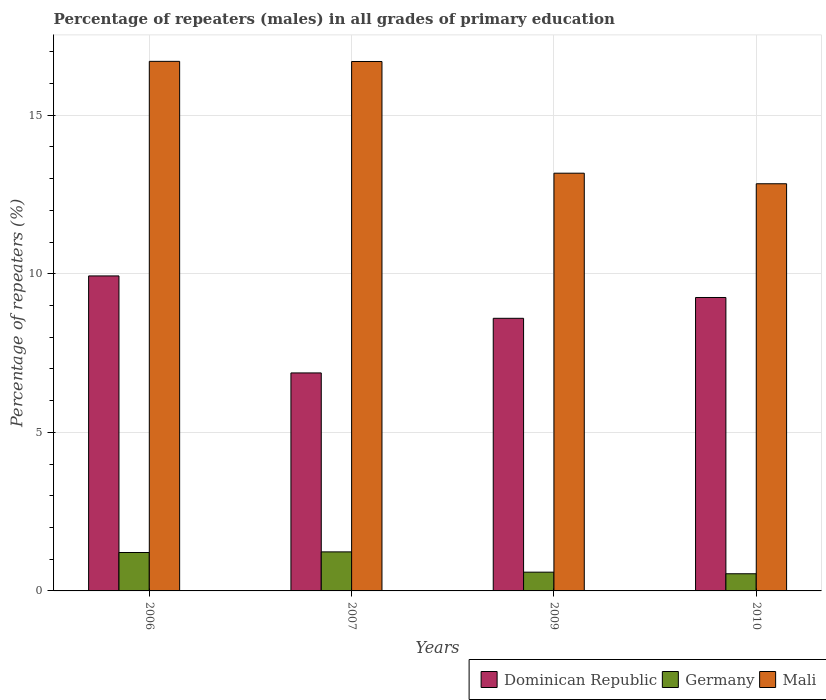Are the number of bars per tick equal to the number of legend labels?
Give a very brief answer. Yes. Are the number of bars on each tick of the X-axis equal?
Provide a short and direct response. Yes. How many bars are there on the 2nd tick from the left?
Ensure brevity in your answer.  3. How many bars are there on the 4th tick from the right?
Your answer should be compact. 3. What is the label of the 4th group of bars from the left?
Offer a very short reply. 2010. In how many cases, is the number of bars for a given year not equal to the number of legend labels?
Keep it short and to the point. 0. What is the percentage of repeaters (males) in Mali in 2006?
Your response must be concise. 16.7. Across all years, what is the maximum percentage of repeaters (males) in Germany?
Provide a succinct answer. 1.23. Across all years, what is the minimum percentage of repeaters (males) in Mali?
Your answer should be very brief. 12.84. In which year was the percentage of repeaters (males) in Mali maximum?
Offer a terse response. 2006. In which year was the percentage of repeaters (males) in Germany minimum?
Keep it short and to the point. 2010. What is the total percentage of repeaters (males) in Germany in the graph?
Your response must be concise. 3.57. What is the difference between the percentage of repeaters (males) in Dominican Republic in 2006 and that in 2009?
Keep it short and to the point. 1.34. What is the difference between the percentage of repeaters (males) in Mali in 2009 and the percentage of repeaters (males) in Dominican Republic in 2006?
Your answer should be very brief. 3.24. What is the average percentage of repeaters (males) in Dominican Republic per year?
Your response must be concise. 8.66. In the year 2007, what is the difference between the percentage of repeaters (males) in Dominican Republic and percentage of repeaters (males) in Germany?
Your answer should be very brief. 5.64. What is the ratio of the percentage of repeaters (males) in Dominican Republic in 2006 to that in 2009?
Give a very brief answer. 1.16. Is the difference between the percentage of repeaters (males) in Dominican Republic in 2007 and 2010 greater than the difference between the percentage of repeaters (males) in Germany in 2007 and 2010?
Your answer should be very brief. No. What is the difference between the highest and the second highest percentage of repeaters (males) in Germany?
Offer a very short reply. 0.02. What is the difference between the highest and the lowest percentage of repeaters (males) in Dominican Republic?
Give a very brief answer. 3.06. In how many years, is the percentage of repeaters (males) in Germany greater than the average percentage of repeaters (males) in Germany taken over all years?
Your answer should be compact. 2. What does the 1st bar from the left in 2006 represents?
Provide a short and direct response. Dominican Republic. What does the 1st bar from the right in 2009 represents?
Offer a very short reply. Mali. Is it the case that in every year, the sum of the percentage of repeaters (males) in Germany and percentage of repeaters (males) in Mali is greater than the percentage of repeaters (males) in Dominican Republic?
Offer a terse response. Yes. How many bars are there?
Your answer should be compact. 12. Are all the bars in the graph horizontal?
Provide a succinct answer. No. Are the values on the major ticks of Y-axis written in scientific E-notation?
Your answer should be compact. No. Does the graph contain any zero values?
Your answer should be very brief. No. How are the legend labels stacked?
Offer a very short reply. Horizontal. What is the title of the graph?
Your response must be concise. Percentage of repeaters (males) in all grades of primary education. What is the label or title of the Y-axis?
Provide a short and direct response. Percentage of repeaters (%). What is the Percentage of repeaters (%) in Dominican Republic in 2006?
Your answer should be very brief. 9.93. What is the Percentage of repeaters (%) in Germany in 2006?
Give a very brief answer. 1.21. What is the Percentage of repeaters (%) of Mali in 2006?
Your answer should be very brief. 16.7. What is the Percentage of repeaters (%) in Dominican Republic in 2007?
Keep it short and to the point. 6.87. What is the Percentage of repeaters (%) of Germany in 2007?
Provide a succinct answer. 1.23. What is the Percentage of repeaters (%) in Mali in 2007?
Ensure brevity in your answer.  16.69. What is the Percentage of repeaters (%) of Dominican Republic in 2009?
Offer a very short reply. 8.6. What is the Percentage of repeaters (%) of Germany in 2009?
Give a very brief answer. 0.59. What is the Percentage of repeaters (%) of Mali in 2009?
Offer a very short reply. 13.17. What is the Percentage of repeaters (%) in Dominican Republic in 2010?
Offer a terse response. 9.25. What is the Percentage of repeaters (%) in Germany in 2010?
Ensure brevity in your answer.  0.54. What is the Percentage of repeaters (%) in Mali in 2010?
Provide a short and direct response. 12.84. Across all years, what is the maximum Percentage of repeaters (%) in Dominican Republic?
Offer a terse response. 9.93. Across all years, what is the maximum Percentage of repeaters (%) in Germany?
Provide a succinct answer. 1.23. Across all years, what is the maximum Percentage of repeaters (%) in Mali?
Your answer should be compact. 16.7. Across all years, what is the minimum Percentage of repeaters (%) of Dominican Republic?
Your response must be concise. 6.87. Across all years, what is the minimum Percentage of repeaters (%) of Germany?
Your response must be concise. 0.54. Across all years, what is the minimum Percentage of repeaters (%) in Mali?
Offer a terse response. 12.84. What is the total Percentage of repeaters (%) of Dominican Republic in the graph?
Offer a terse response. 34.65. What is the total Percentage of repeaters (%) of Germany in the graph?
Provide a short and direct response. 3.57. What is the total Percentage of repeaters (%) in Mali in the graph?
Provide a succinct answer. 59.39. What is the difference between the Percentage of repeaters (%) of Dominican Republic in 2006 and that in 2007?
Your response must be concise. 3.06. What is the difference between the Percentage of repeaters (%) in Germany in 2006 and that in 2007?
Your answer should be very brief. -0.02. What is the difference between the Percentage of repeaters (%) of Mali in 2006 and that in 2007?
Your answer should be compact. 0. What is the difference between the Percentage of repeaters (%) in Dominican Republic in 2006 and that in 2009?
Keep it short and to the point. 1.34. What is the difference between the Percentage of repeaters (%) in Germany in 2006 and that in 2009?
Keep it short and to the point. 0.62. What is the difference between the Percentage of repeaters (%) in Mali in 2006 and that in 2009?
Give a very brief answer. 3.53. What is the difference between the Percentage of repeaters (%) of Dominican Republic in 2006 and that in 2010?
Provide a short and direct response. 0.68. What is the difference between the Percentage of repeaters (%) in Germany in 2006 and that in 2010?
Keep it short and to the point. 0.67. What is the difference between the Percentage of repeaters (%) of Mali in 2006 and that in 2010?
Make the answer very short. 3.86. What is the difference between the Percentage of repeaters (%) in Dominican Republic in 2007 and that in 2009?
Keep it short and to the point. -1.72. What is the difference between the Percentage of repeaters (%) in Germany in 2007 and that in 2009?
Give a very brief answer. 0.64. What is the difference between the Percentage of repeaters (%) of Mali in 2007 and that in 2009?
Offer a very short reply. 3.52. What is the difference between the Percentage of repeaters (%) of Dominican Republic in 2007 and that in 2010?
Your answer should be compact. -2.38. What is the difference between the Percentage of repeaters (%) in Germany in 2007 and that in 2010?
Offer a terse response. 0.69. What is the difference between the Percentage of repeaters (%) of Mali in 2007 and that in 2010?
Provide a short and direct response. 3.85. What is the difference between the Percentage of repeaters (%) of Dominican Republic in 2009 and that in 2010?
Ensure brevity in your answer.  -0.66. What is the difference between the Percentage of repeaters (%) in Germany in 2009 and that in 2010?
Your answer should be compact. 0.05. What is the difference between the Percentage of repeaters (%) in Mali in 2009 and that in 2010?
Provide a succinct answer. 0.33. What is the difference between the Percentage of repeaters (%) of Dominican Republic in 2006 and the Percentage of repeaters (%) of Germany in 2007?
Provide a succinct answer. 8.7. What is the difference between the Percentage of repeaters (%) in Dominican Republic in 2006 and the Percentage of repeaters (%) in Mali in 2007?
Your answer should be compact. -6.76. What is the difference between the Percentage of repeaters (%) of Germany in 2006 and the Percentage of repeaters (%) of Mali in 2007?
Your answer should be compact. -15.48. What is the difference between the Percentage of repeaters (%) in Dominican Republic in 2006 and the Percentage of repeaters (%) in Germany in 2009?
Give a very brief answer. 9.34. What is the difference between the Percentage of repeaters (%) in Dominican Republic in 2006 and the Percentage of repeaters (%) in Mali in 2009?
Give a very brief answer. -3.24. What is the difference between the Percentage of repeaters (%) of Germany in 2006 and the Percentage of repeaters (%) of Mali in 2009?
Your answer should be very brief. -11.96. What is the difference between the Percentage of repeaters (%) of Dominican Republic in 2006 and the Percentage of repeaters (%) of Germany in 2010?
Make the answer very short. 9.39. What is the difference between the Percentage of repeaters (%) in Dominican Republic in 2006 and the Percentage of repeaters (%) in Mali in 2010?
Provide a succinct answer. -2.91. What is the difference between the Percentage of repeaters (%) in Germany in 2006 and the Percentage of repeaters (%) in Mali in 2010?
Make the answer very short. -11.63. What is the difference between the Percentage of repeaters (%) of Dominican Republic in 2007 and the Percentage of repeaters (%) of Germany in 2009?
Provide a succinct answer. 6.28. What is the difference between the Percentage of repeaters (%) of Dominican Republic in 2007 and the Percentage of repeaters (%) of Mali in 2009?
Provide a succinct answer. -6.3. What is the difference between the Percentage of repeaters (%) in Germany in 2007 and the Percentage of repeaters (%) in Mali in 2009?
Provide a succinct answer. -11.94. What is the difference between the Percentage of repeaters (%) in Dominican Republic in 2007 and the Percentage of repeaters (%) in Germany in 2010?
Ensure brevity in your answer.  6.33. What is the difference between the Percentage of repeaters (%) in Dominican Republic in 2007 and the Percentage of repeaters (%) in Mali in 2010?
Make the answer very short. -5.96. What is the difference between the Percentage of repeaters (%) in Germany in 2007 and the Percentage of repeaters (%) in Mali in 2010?
Ensure brevity in your answer.  -11.61. What is the difference between the Percentage of repeaters (%) in Dominican Republic in 2009 and the Percentage of repeaters (%) in Germany in 2010?
Provide a short and direct response. 8.05. What is the difference between the Percentage of repeaters (%) of Dominican Republic in 2009 and the Percentage of repeaters (%) of Mali in 2010?
Your answer should be compact. -4.24. What is the difference between the Percentage of repeaters (%) of Germany in 2009 and the Percentage of repeaters (%) of Mali in 2010?
Ensure brevity in your answer.  -12.25. What is the average Percentage of repeaters (%) of Dominican Republic per year?
Provide a short and direct response. 8.66. What is the average Percentage of repeaters (%) of Germany per year?
Provide a short and direct response. 0.89. What is the average Percentage of repeaters (%) of Mali per year?
Make the answer very short. 14.85. In the year 2006, what is the difference between the Percentage of repeaters (%) of Dominican Republic and Percentage of repeaters (%) of Germany?
Provide a short and direct response. 8.72. In the year 2006, what is the difference between the Percentage of repeaters (%) of Dominican Republic and Percentage of repeaters (%) of Mali?
Your answer should be compact. -6.76. In the year 2006, what is the difference between the Percentage of repeaters (%) in Germany and Percentage of repeaters (%) in Mali?
Your response must be concise. -15.48. In the year 2007, what is the difference between the Percentage of repeaters (%) of Dominican Republic and Percentage of repeaters (%) of Germany?
Ensure brevity in your answer.  5.64. In the year 2007, what is the difference between the Percentage of repeaters (%) in Dominican Republic and Percentage of repeaters (%) in Mali?
Provide a short and direct response. -9.82. In the year 2007, what is the difference between the Percentage of repeaters (%) in Germany and Percentage of repeaters (%) in Mali?
Offer a terse response. -15.46. In the year 2009, what is the difference between the Percentage of repeaters (%) of Dominican Republic and Percentage of repeaters (%) of Germany?
Ensure brevity in your answer.  8. In the year 2009, what is the difference between the Percentage of repeaters (%) of Dominican Republic and Percentage of repeaters (%) of Mali?
Ensure brevity in your answer.  -4.57. In the year 2009, what is the difference between the Percentage of repeaters (%) in Germany and Percentage of repeaters (%) in Mali?
Your response must be concise. -12.58. In the year 2010, what is the difference between the Percentage of repeaters (%) of Dominican Republic and Percentage of repeaters (%) of Germany?
Give a very brief answer. 8.71. In the year 2010, what is the difference between the Percentage of repeaters (%) in Dominican Republic and Percentage of repeaters (%) in Mali?
Offer a terse response. -3.59. In the year 2010, what is the difference between the Percentage of repeaters (%) in Germany and Percentage of repeaters (%) in Mali?
Your response must be concise. -12.3. What is the ratio of the Percentage of repeaters (%) of Dominican Republic in 2006 to that in 2007?
Offer a very short reply. 1.45. What is the ratio of the Percentage of repeaters (%) in Germany in 2006 to that in 2007?
Provide a succinct answer. 0.98. What is the ratio of the Percentage of repeaters (%) in Dominican Republic in 2006 to that in 2009?
Your answer should be very brief. 1.16. What is the ratio of the Percentage of repeaters (%) in Germany in 2006 to that in 2009?
Your answer should be very brief. 2.05. What is the ratio of the Percentage of repeaters (%) in Mali in 2006 to that in 2009?
Give a very brief answer. 1.27. What is the ratio of the Percentage of repeaters (%) of Dominican Republic in 2006 to that in 2010?
Offer a terse response. 1.07. What is the ratio of the Percentage of repeaters (%) of Germany in 2006 to that in 2010?
Offer a very short reply. 2.24. What is the ratio of the Percentage of repeaters (%) of Mali in 2006 to that in 2010?
Provide a short and direct response. 1.3. What is the ratio of the Percentage of repeaters (%) of Dominican Republic in 2007 to that in 2009?
Your response must be concise. 0.8. What is the ratio of the Percentage of repeaters (%) in Germany in 2007 to that in 2009?
Ensure brevity in your answer.  2.08. What is the ratio of the Percentage of repeaters (%) of Mali in 2007 to that in 2009?
Keep it short and to the point. 1.27. What is the ratio of the Percentage of repeaters (%) in Dominican Republic in 2007 to that in 2010?
Your answer should be very brief. 0.74. What is the ratio of the Percentage of repeaters (%) of Germany in 2007 to that in 2010?
Your answer should be very brief. 2.27. What is the ratio of the Percentage of repeaters (%) of Mali in 2007 to that in 2010?
Provide a succinct answer. 1.3. What is the ratio of the Percentage of repeaters (%) in Dominican Republic in 2009 to that in 2010?
Your response must be concise. 0.93. What is the ratio of the Percentage of repeaters (%) in Germany in 2009 to that in 2010?
Make the answer very short. 1.09. What is the ratio of the Percentage of repeaters (%) of Mali in 2009 to that in 2010?
Your answer should be very brief. 1.03. What is the difference between the highest and the second highest Percentage of repeaters (%) in Dominican Republic?
Your answer should be very brief. 0.68. What is the difference between the highest and the second highest Percentage of repeaters (%) of Germany?
Give a very brief answer. 0.02. What is the difference between the highest and the second highest Percentage of repeaters (%) in Mali?
Offer a very short reply. 0. What is the difference between the highest and the lowest Percentage of repeaters (%) of Dominican Republic?
Provide a short and direct response. 3.06. What is the difference between the highest and the lowest Percentage of repeaters (%) in Germany?
Ensure brevity in your answer.  0.69. What is the difference between the highest and the lowest Percentage of repeaters (%) of Mali?
Keep it short and to the point. 3.86. 